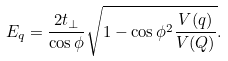Convert formula to latex. <formula><loc_0><loc_0><loc_500><loc_500>E _ { q } = \frac { 2 t _ { \perp } } { \cos \phi } \sqrt { 1 - \cos \phi ^ { 2 } \frac { V ( { q } ) } { V ( { Q } ) } } .</formula> 